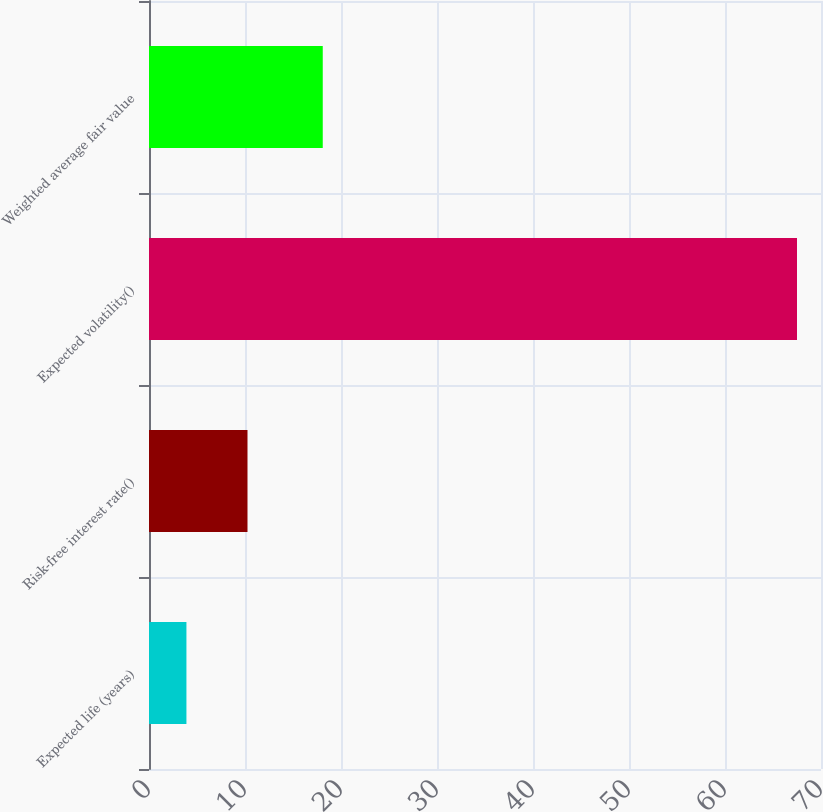<chart> <loc_0><loc_0><loc_500><loc_500><bar_chart><fcel>Expected life (years)<fcel>Risk-free interest rate()<fcel>Expected volatility()<fcel>Weighted average fair value<nl><fcel>3.9<fcel>10.26<fcel>67.5<fcel>18.1<nl></chart> 